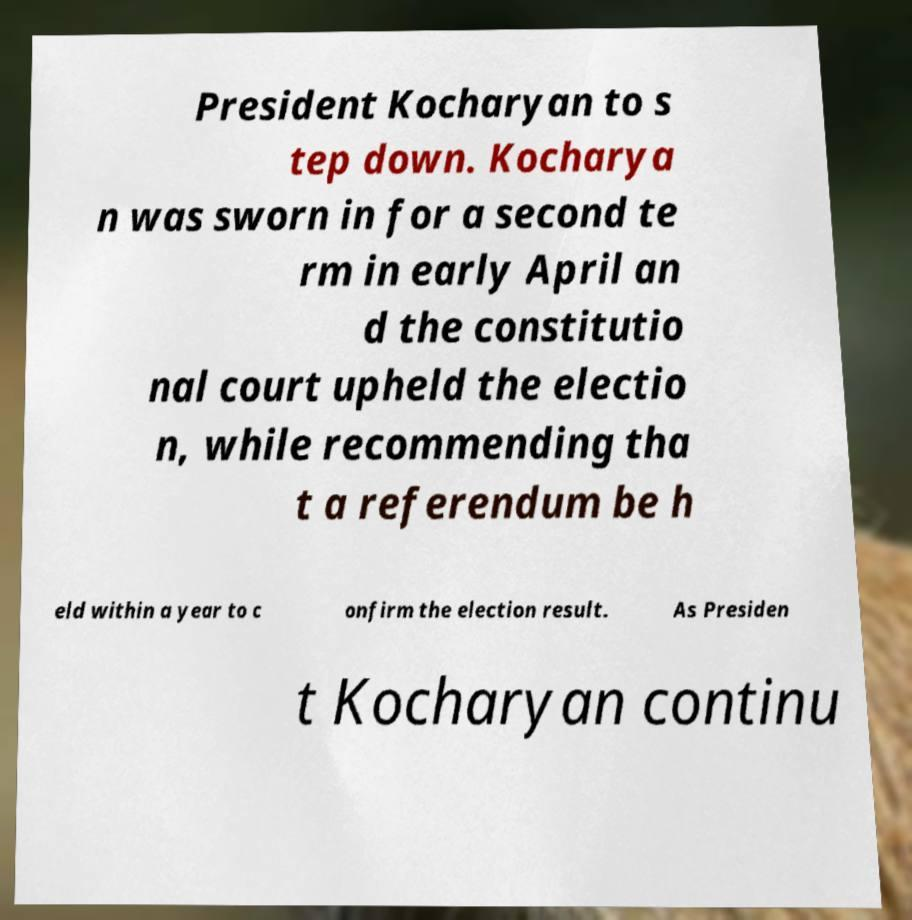Please read and relay the text visible in this image. What does it say? President Kocharyan to s tep down. Kocharya n was sworn in for a second te rm in early April an d the constitutio nal court upheld the electio n, while recommending tha t a referendum be h eld within a year to c onfirm the election result. As Presiden t Kocharyan continu 